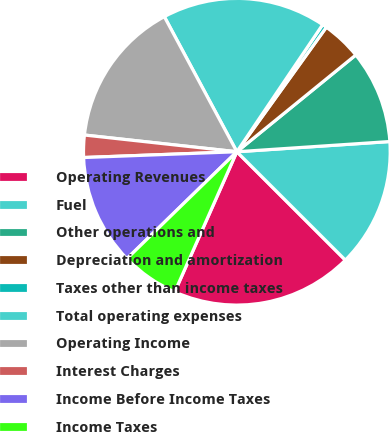Convert chart. <chart><loc_0><loc_0><loc_500><loc_500><pie_chart><fcel>Operating Revenues<fcel>Fuel<fcel>Other operations and<fcel>Depreciation and amortization<fcel>Taxes other than income taxes<fcel>Total operating expenses<fcel>Operating Income<fcel>Interest Charges<fcel>Income Before Income Taxes<fcel>Income Taxes<nl><fcel>19.15%<fcel>13.55%<fcel>9.81%<fcel>4.21%<fcel>0.47%<fcel>17.29%<fcel>15.42%<fcel>2.34%<fcel>11.68%<fcel>6.08%<nl></chart> 